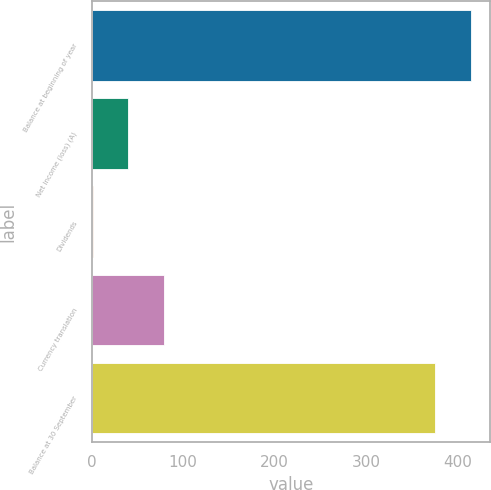<chart> <loc_0><loc_0><loc_500><loc_500><bar_chart><fcel>Balance at beginning of year<fcel>Net income (loss) (A)<fcel>Dividends<fcel>Currency translation<fcel>Balance at 30 September<nl><fcel>414.94<fcel>40.24<fcel>1.1<fcel>79.38<fcel>375.8<nl></chart> 